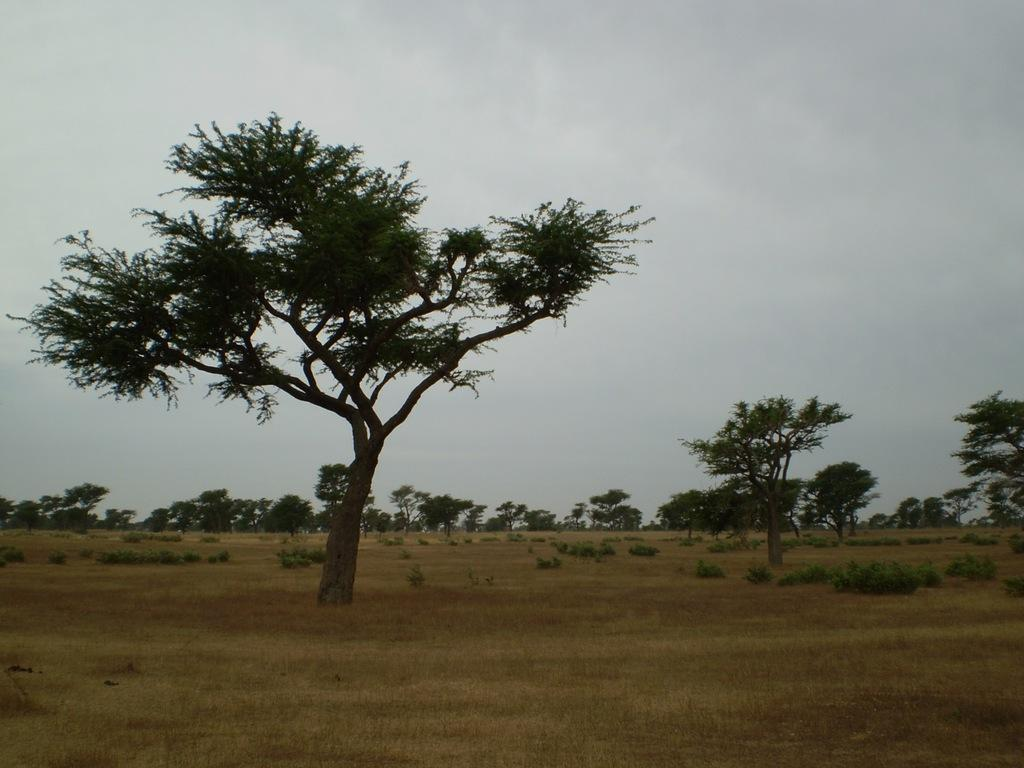What type of vegetation can be seen in the image? There are trees in the image. Where are the trees located? The trees are in an open garden. What is visible at the top of the image? The sky is visible at the top of the image. What scent can be detected from the trees in the image? There is no information about the scent of the trees in the image, so it cannot be determined. 